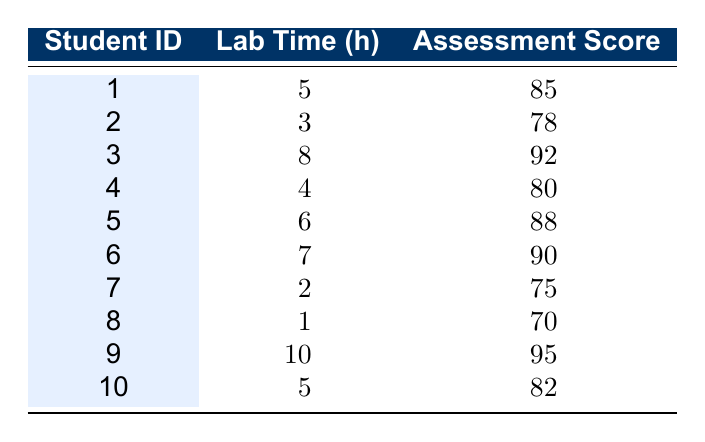What is the practical assessment score of Student ID 3? The table shows that Student ID 3 has a practical assessment score of 92.
Answer: 92 What is the total time spent in the lab by all students? By adding the lab hours: 5 + 3 + 8 + 4 + 6 + 7 + 2 + 1 + 10 + 5 = 51.
Answer: 51 hours Which student spent the least time in the lab? Referring to the table, Student ID 8 spent the least time with only 1 hour in the lab.
Answer: Student ID 8 What is the average practical assessment score of all students? To find the average, we sum the scores (85 + 78 + 92 + 80 + 88 + 90 + 75 + 70 + 95 + 82) =  830 and divide by 10 (total students), giving 830/10 = 83.
Answer: 83 Did any student score below 75 in the practical assessment? Looking at the practical assessment scores, Student ID 8 scored 70, which is below 75.
Answer: Yes Which student has the highest practical assessment score? The highest score in the table is 95, which belongs to Student ID 9.
Answer: Student ID 9 What is the difference between the highest and lowest practical assessment scores? The highest score is 95 (Student ID 9) and the lowest is 70 (Student ID 8). The difference is 95 - 70 = 25.
Answer: 25 If a student spends 4 hours in the lab, what is the practical assessment score they likely achieve based on the table data? Based on the scores for students spending 4 hours (80), it is closest to that score for the practical assessment. Hence, if a student spends 4 hours, they would likely score around 80.
Answer: 80 How many students scored above 85 in their practical assessment? Referring to the scores, students with ID 3, 5, 6, and 9 scored above 85. Thus, there are 4 students.
Answer: 4 students 